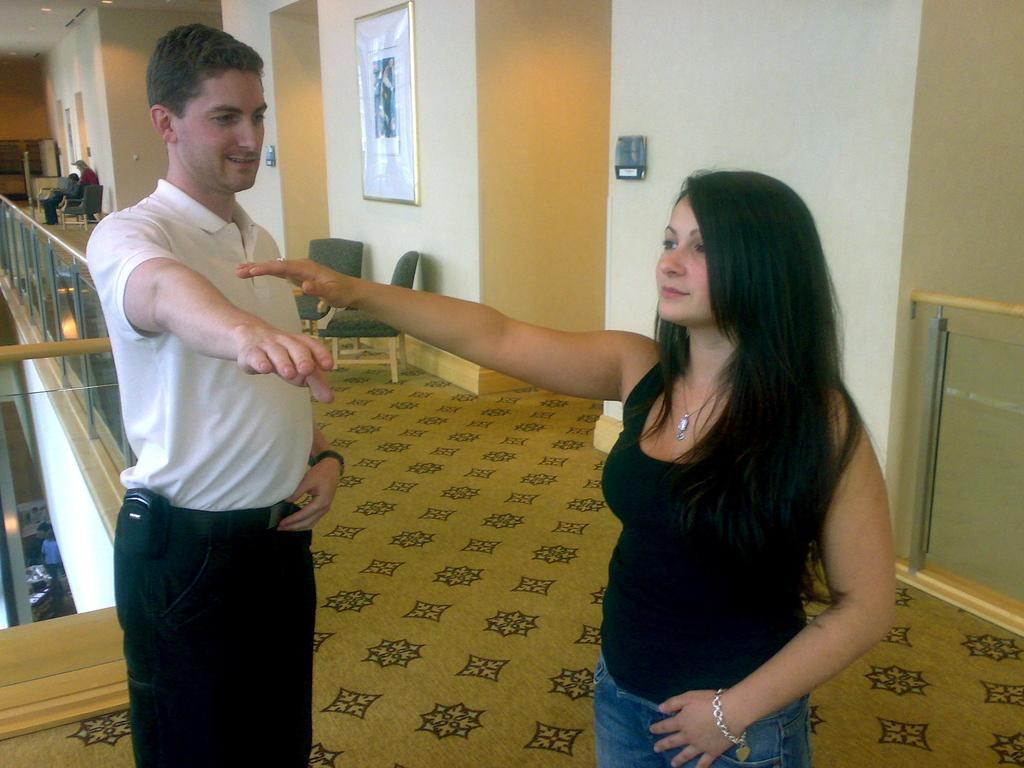Please provide a concise description of this image. In this image I can see a man and a woman are standing. In the background I can see chairs, frame and other objects attached to the wall. Here I can see glass fence and other objects on the floor. 